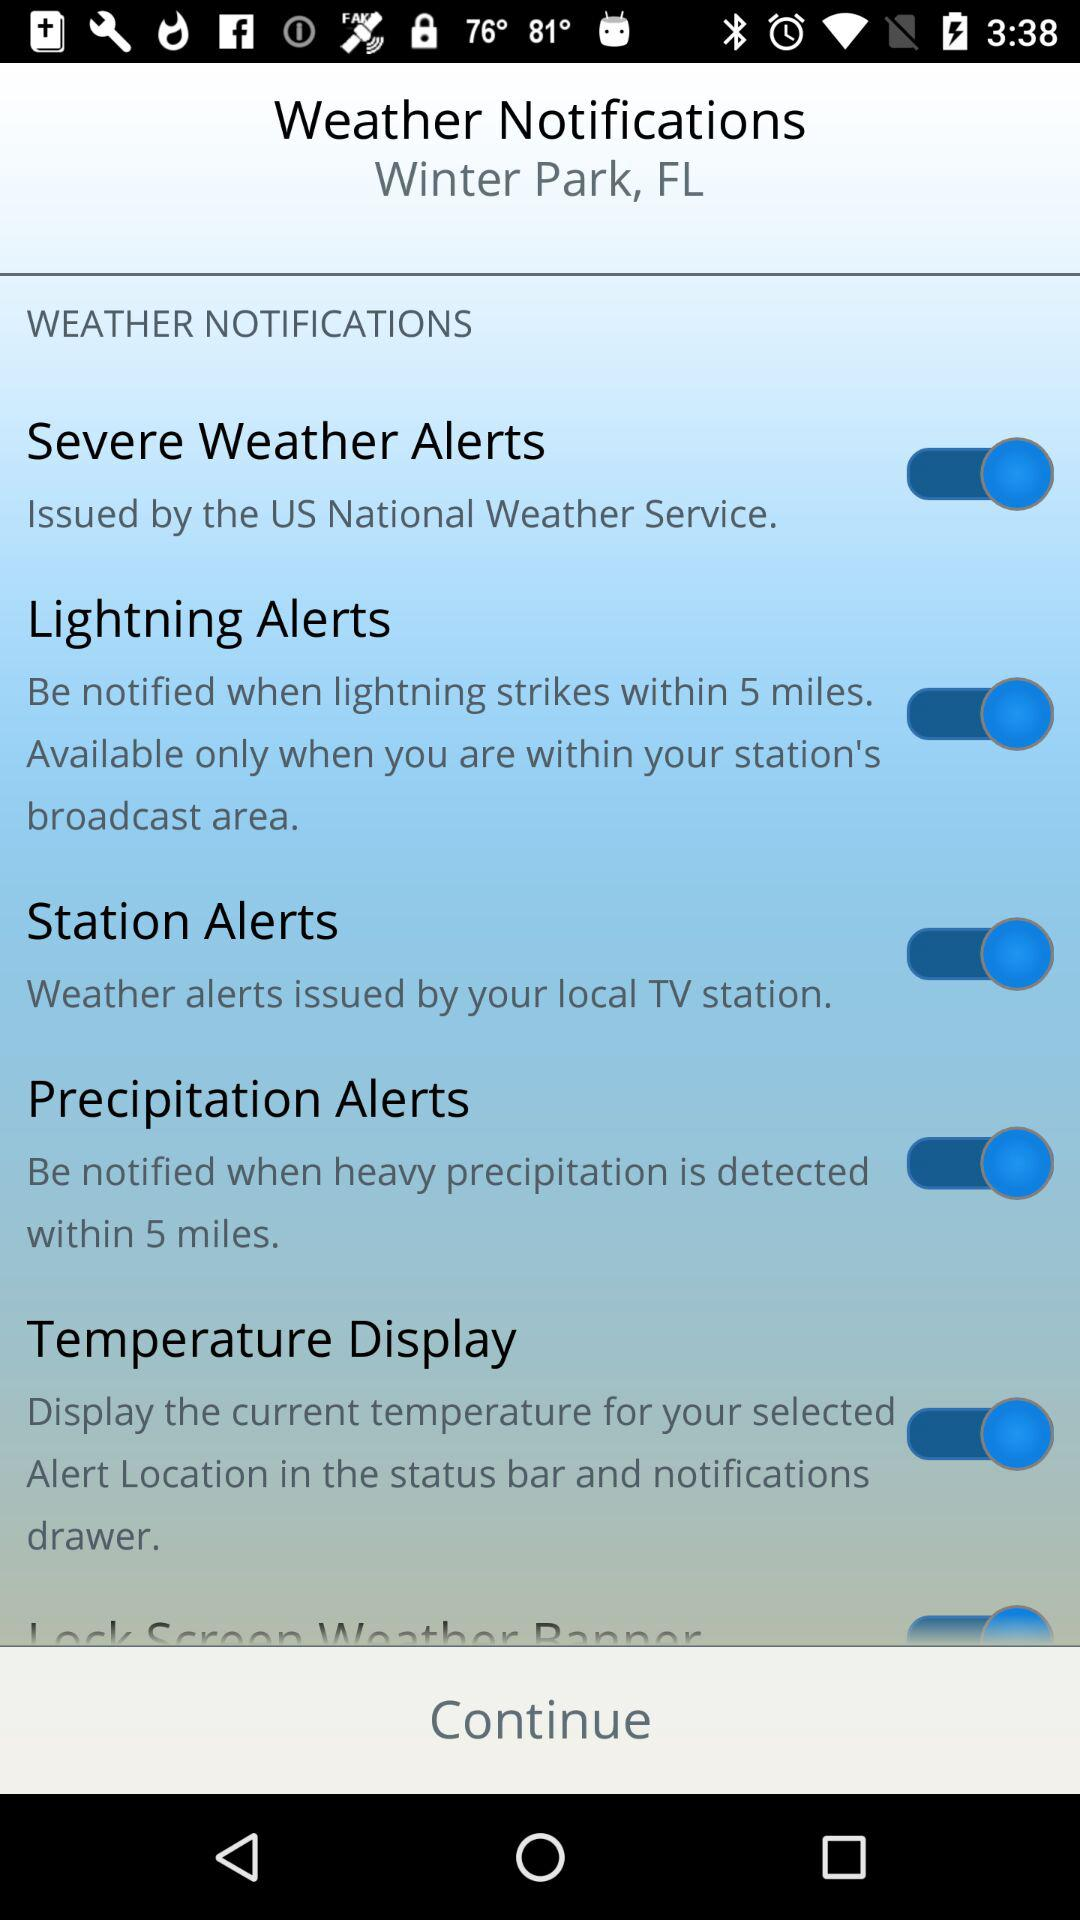What is the status of the "Precipitation Alerts" setting? The status is "on". 